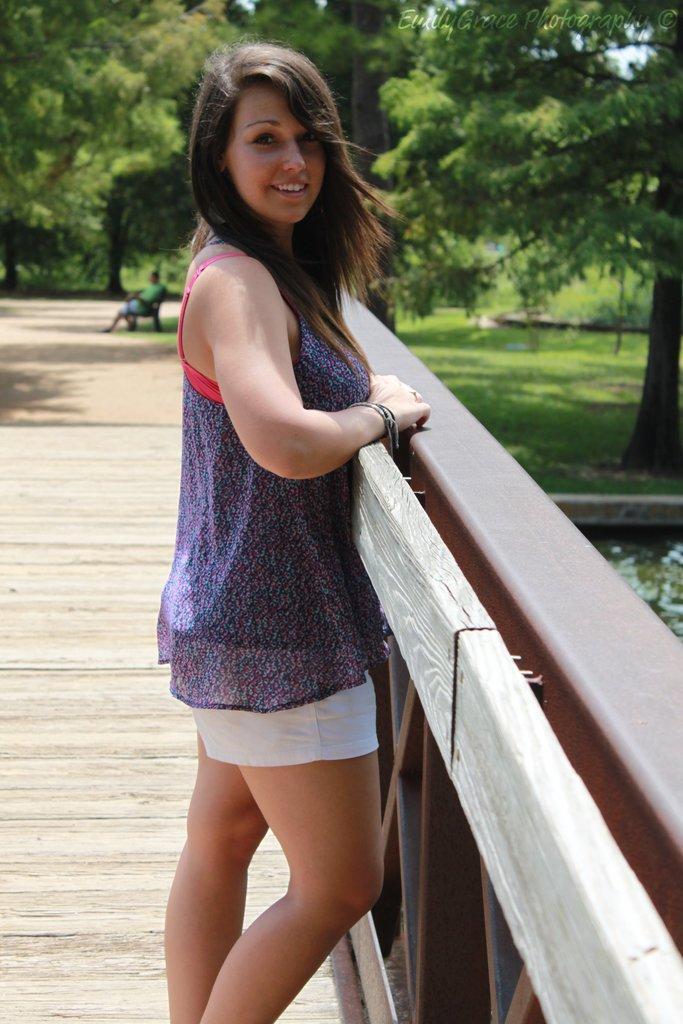Can you describe this image briefly? In the center of the image we can see a woman standing on the path and smiling. On the right we can see the fence. In the background we can see a man sitting on the chair. We can also see the trees and also the grass. 